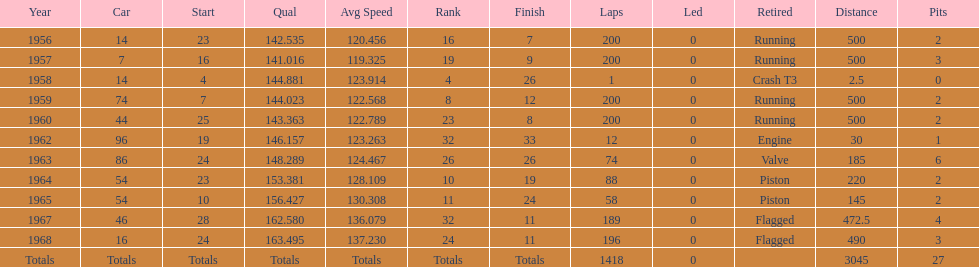How many times was bob veith ranked higher than 10 at an indy 500? 2. 